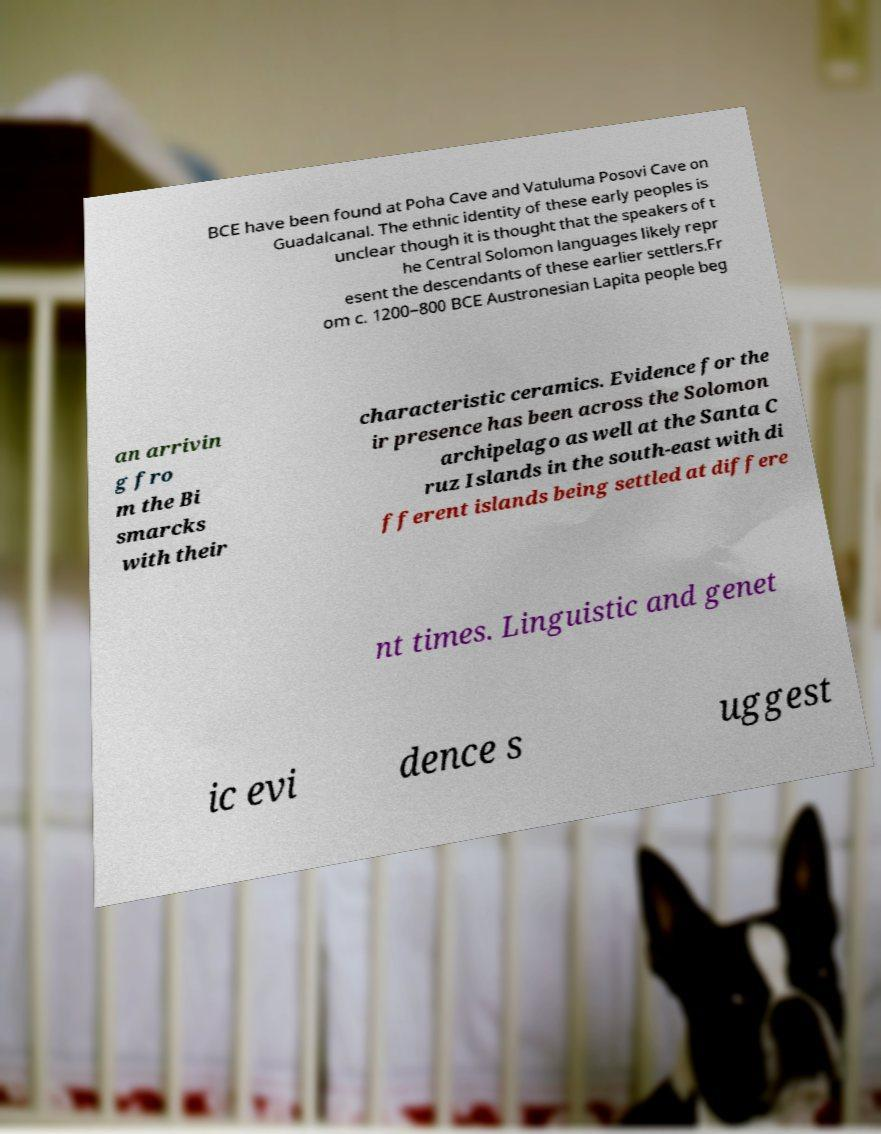Can you accurately transcribe the text from the provided image for me? BCE have been found at Poha Cave and Vatuluma Posovi Cave on Guadalcanal. The ethnic identity of these early peoples is unclear though it is thought that the speakers of t he Central Solomon languages likely repr esent the descendants of these earlier settlers.Fr om c. 1200–800 BCE Austronesian Lapita people beg an arrivin g fro m the Bi smarcks with their characteristic ceramics. Evidence for the ir presence has been across the Solomon archipelago as well at the Santa C ruz Islands in the south-east with di fferent islands being settled at differe nt times. Linguistic and genet ic evi dence s uggest 